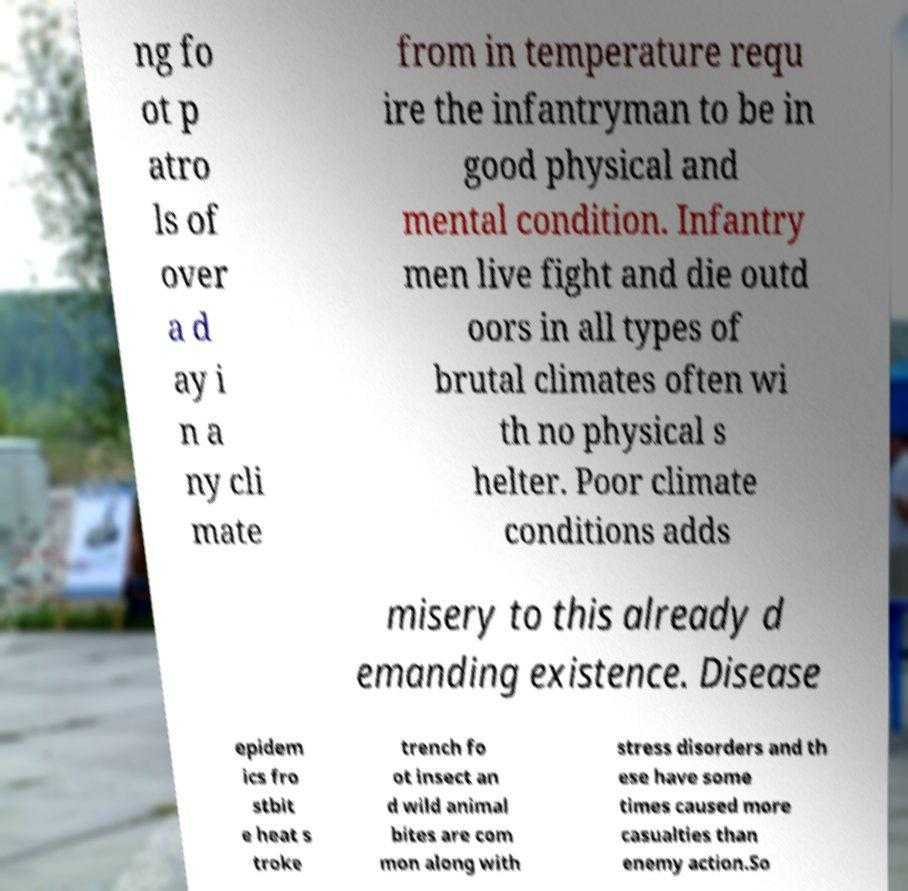There's text embedded in this image that I need extracted. Can you transcribe it verbatim? ng fo ot p atro ls of over a d ay i n a ny cli mate from in temperature requ ire the infantryman to be in good physical and mental condition. Infantry men live fight and die outd oors in all types of brutal climates often wi th no physical s helter. Poor climate conditions adds misery to this already d emanding existence. Disease epidem ics fro stbit e heat s troke trench fo ot insect an d wild animal bites are com mon along with stress disorders and th ese have some times caused more casualties than enemy action.So 